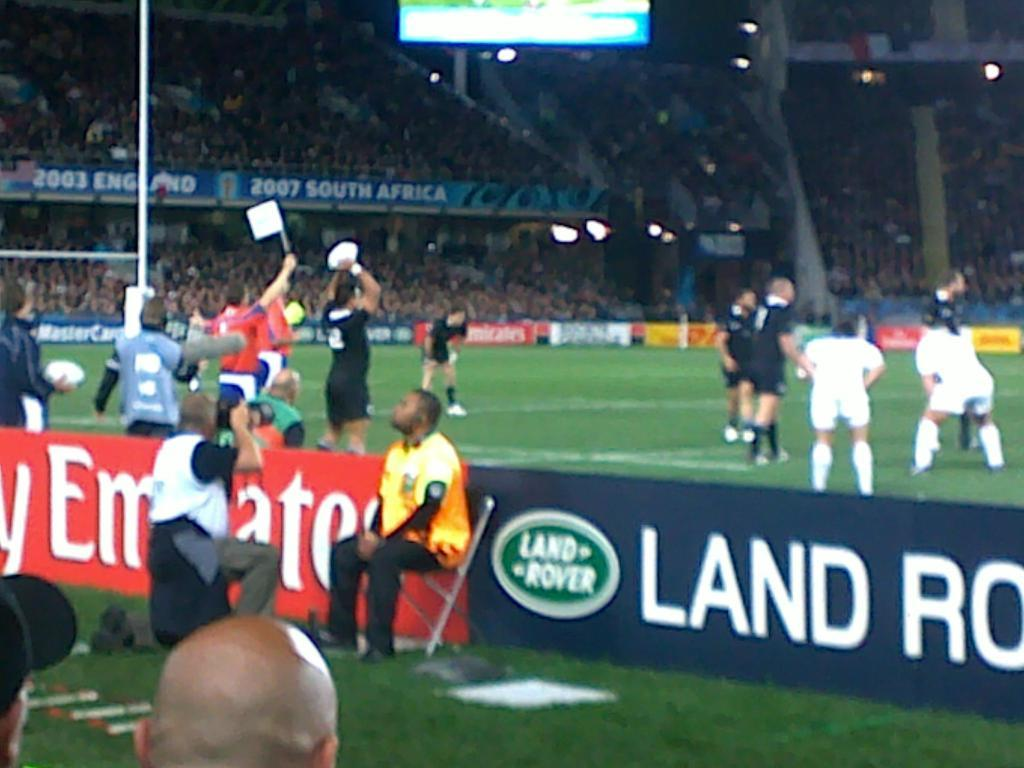<image>
Present a compact description of the photo's key features. A Land Rover ad lines the side of a soccer field where a player in yellow is being photographed. 